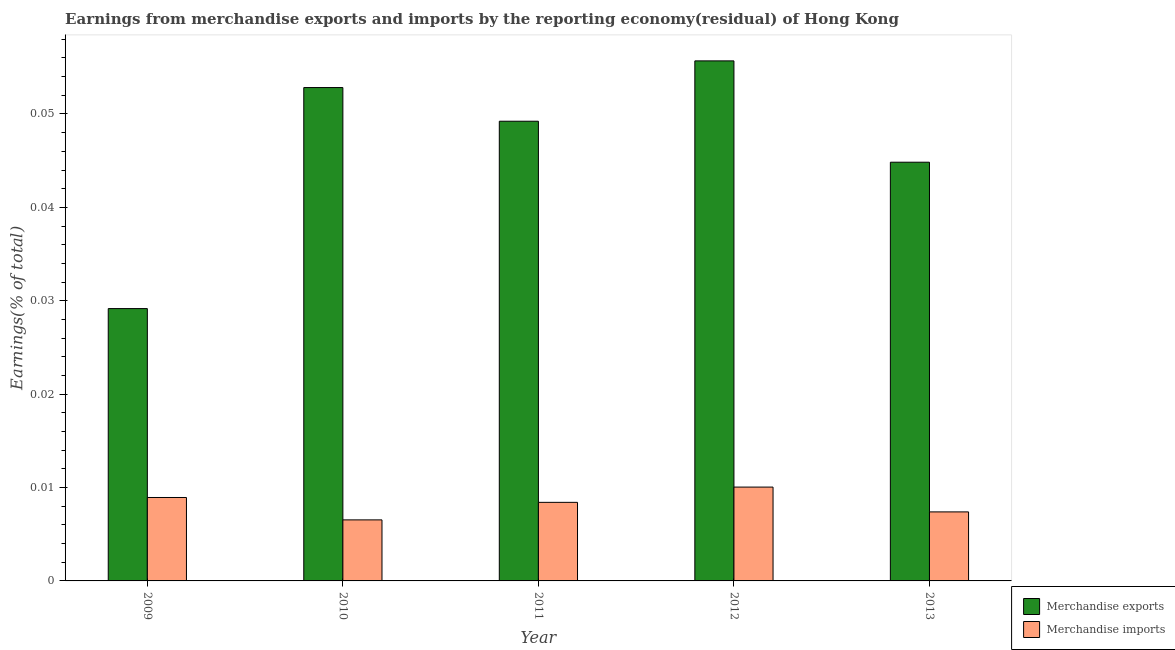How many different coloured bars are there?
Your answer should be very brief. 2. How many groups of bars are there?
Your answer should be very brief. 5. Are the number of bars per tick equal to the number of legend labels?
Your answer should be compact. Yes. Are the number of bars on each tick of the X-axis equal?
Your answer should be very brief. Yes. How many bars are there on the 3rd tick from the left?
Offer a very short reply. 2. What is the label of the 3rd group of bars from the left?
Offer a very short reply. 2011. What is the earnings from merchandise exports in 2010?
Give a very brief answer. 0.05. Across all years, what is the maximum earnings from merchandise imports?
Ensure brevity in your answer.  0.01. Across all years, what is the minimum earnings from merchandise imports?
Provide a succinct answer. 0.01. What is the total earnings from merchandise exports in the graph?
Give a very brief answer. 0.23. What is the difference between the earnings from merchandise exports in 2012 and that in 2013?
Keep it short and to the point. 0.01. What is the difference between the earnings from merchandise imports in 2011 and the earnings from merchandise exports in 2009?
Make the answer very short. -0. What is the average earnings from merchandise imports per year?
Your answer should be very brief. 0.01. In the year 2012, what is the difference between the earnings from merchandise exports and earnings from merchandise imports?
Your answer should be compact. 0. In how many years, is the earnings from merchandise exports greater than 0.044 %?
Your answer should be compact. 4. What is the ratio of the earnings from merchandise imports in 2009 to that in 2013?
Keep it short and to the point. 1.21. Is the earnings from merchandise exports in 2009 less than that in 2012?
Your answer should be compact. Yes. What is the difference between the highest and the second highest earnings from merchandise exports?
Provide a succinct answer. 0. What is the difference between the highest and the lowest earnings from merchandise imports?
Offer a very short reply. 0. In how many years, is the earnings from merchandise imports greater than the average earnings from merchandise imports taken over all years?
Ensure brevity in your answer.  3. Are all the bars in the graph horizontal?
Keep it short and to the point. No. Does the graph contain any zero values?
Your answer should be compact. No. Does the graph contain grids?
Keep it short and to the point. No. Where does the legend appear in the graph?
Ensure brevity in your answer.  Bottom right. How many legend labels are there?
Ensure brevity in your answer.  2. How are the legend labels stacked?
Make the answer very short. Vertical. What is the title of the graph?
Give a very brief answer. Earnings from merchandise exports and imports by the reporting economy(residual) of Hong Kong. Does "% of GNI" appear as one of the legend labels in the graph?
Provide a short and direct response. No. What is the label or title of the X-axis?
Keep it short and to the point. Year. What is the label or title of the Y-axis?
Provide a short and direct response. Earnings(% of total). What is the Earnings(% of total) of Merchandise exports in 2009?
Provide a succinct answer. 0.03. What is the Earnings(% of total) of Merchandise imports in 2009?
Your answer should be compact. 0.01. What is the Earnings(% of total) of Merchandise exports in 2010?
Make the answer very short. 0.05. What is the Earnings(% of total) of Merchandise imports in 2010?
Give a very brief answer. 0.01. What is the Earnings(% of total) in Merchandise exports in 2011?
Your answer should be compact. 0.05. What is the Earnings(% of total) of Merchandise imports in 2011?
Your response must be concise. 0.01. What is the Earnings(% of total) of Merchandise exports in 2012?
Keep it short and to the point. 0.06. What is the Earnings(% of total) in Merchandise imports in 2012?
Your answer should be very brief. 0.01. What is the Earnings(% of total) of Merchandise exports in 2013?
Make the answer very short. 0.04. What is the Earnings(% of total) of Merchandise imports in 2013?
Your answer should be compact. 0.01. Across all years, what is the maximum Earnings(% of total) of Merchandise exports?
Make the answer very short. 0.06. Across all years, what is the maximum Earnings(% of total) of Merchandise imports?
Make the answer very short. 0.01. Across all years, what is the minimum Earnings(% of total) of Merchandise exports?
Your response must be concise. 0.03. Across all years, what is the minimum Earnings(% of total) in Merchandise imports?
Give a very brief answer. 0.01. What is the total Earnings(% of total) in Merchandise exports in the graph?
Provide a short and direct response. 0.23. What is the total Earnings(% of total) in Merchandise imports in the graph?
Offer a very short reply. 0.04. What is the difference between the Earnings(% of total) in Merchandise exports in 2009 and that in 2010?
Give a very brief answer. -0.02. What is the difference between the Earnings(% of total) in Merchandise imports in 2009 and that in 2010?
Your response must be concise. 0. What is the difference between the Earnings(% of total) in Merchandise exports in 2009 and that in 2011?
Make the answer very short. -0.02. What is the difference between the Earnings(% of total) in Merchandise exports in 2009 and that in 2012?
Give a very brief answer. -0.03. What is the difference between the Earnings(% of total) of Merchandise imports in 2009 and that in 2012?
Provide a succinct answer. -0. What is the difference between the Earnings(% of total) of Merchandise exports in 2009 and that in 2013?
Give a very brief answer. -0.02. What is the difference between the Earnings(% of total) of Merchandise imports in 2009 and that in 2013?
Ensure brevity in your answer.  0. What is the difference between the Earnings(% of total) in Merchandise exports in 2010 and that in 2011?
Offer a very short reply. 0. What is the difference between the Earnings(% of total) in Merchandise imports in 2010 and that in 2011?
Offer a very short reply. -0. What is the difference between the Earnings(% of total) of Merchandise exports in 2010 and that in 2012?
Offer a very short reply. -0. What is the difference between the Earnings(% of total) in Merchandise imports in 2010 and that in 2012?
Ensure brevity in your answer.  -0. What is the difference between the Earnings(% of total) of Merchandise exports in 2010 and that in 2013?
Keep it short and to the point. 0.01. What is the difference between the Earnings(% of total) in Merchandise imports in 2010 and that in 2013?
Make the answer very short. -0. What is the difference between the Earnings(% of total) of Merchandise exports in 2011 and that in 2012?
Provide a short and direct response. -0.01. What is the difference between the Earnings(% of total) of Merchandise imports in 2011 and that in 2012?
Give a very brief answer. -0. What is the difference between the Earnings(% of total) in Merchandise exports in 2011 and that in 2013?
Offer a terse response. 0. What is the difference between the Earnings(% of total) of Merchandise exports in 2012 and that in 2013?
Your response must be concise. 0.01. What is the difference between the Earnings(% of total) in Merchandise imports in 2012 and that in 2013?
Provide a short and direct response. 0. What is the difference between the Earnings(% of total) in Merchandise exports in 2009 and the Earnings(% of total) in Merchandise imports in 2010?
Give a very brief answer. 0.02. What is the difference between the Earnings(% of total) of Merchandise exports in 2009 and the Earnings(% of total) of Merchandise imports in 2011?
Provide a short and direct response. 0.02. What is the difference between the Earnings(% of total) of Merchandise exports in 2009 and the Earnings(% of total) of Merchandise imports in 2012?
Give a very brief answer. 0.02. What is the difference between the Earnings(% of total) in Merchandise exports in 2009 and the Earnings(% of total) in Merchandise imports in 2013?
Your answer should be very brief. 0.02. What is the difference between the Earnings(% of total) in Merchandise exports in 2010 and the Earnings(% of total) in Merchandise imports in 2011?
Make the answer very short. 0.04. What is the difference between the Earnings(% of total) of Merchandise exports in 2010 and the Earnings(% of total) of Merchandise imports in 2012?
Offer a very short reply. 0.04. What is the difference between the Earnings(% of total) in Merchandise exports in 2010 and the Earnings(% of total) in Merchandise imports in 2013?
Give a very brief answer. 0.05. What is the difference between the Earnings(% of total) of Merchandise exports in 2011 and the Earnings(% of total) of Merchandise imports in 2012?
Give a very brief answer. 0.04. What is the difference between the Earnings(% of total) of Merchandise exports in 2011 and the Earnings(% of total) of Merchandise imports in 2013?
Your response must be concise. 0.04. What is the difference between the Earnings(% of total) of Merchandise exports in 2012 and the Earnings(% of total) of Merchandise imports in 2013?
Ensure brevity in your answer.  0.05. What is the average Earnings(% of total) of Merchandise exports per year?
Your answer should be very brief. 0.05. What is the average Earnings(% of total) of Merchandise imports per year?
Your answer should be very brief. 0.01. In the year 2009, what is the difference between the Earnings(% of total) in Merchandise exports and Earnings(% of total) in Merchandise imports?
Offer a terse response. 0.02. In the year 2010, what is the difference between the Earnings(% of total) of Merchandise exports and Earnings(% of total) of Merchandise imports?
Ensure brevity in your answer.  0.05. In the year 2011, what is the difference between the Earnings(% of total) in Merchandise exports and Earnings(% of total) in Merchandise imports?
Provide a succinct answer. 0.04. In the year 2012, what is the difference between the Earnings(% of total) in Merchandise exports and Earnings(% of total) in Merchandise imports?
Make the answer very short. 0.05. In the year 2013, what is the difference between the Earnings(% of total) of Merchandise exports and Earnings(% of total) of Merchandise imports?
Offer a very short reply. 0.04. What is the ratio of the Earnings(% of total) in Merchandise exports in 2009 to that in 2010?
Your answer should be very brief. 0.55. What is the ratio of the Earnings(% of total) in Merchandise imports in 2009 to that in 2010?
Provide a short and direct response. 1.37. What is the ratio of the Earnings(% of total) of Merchandise exports in 2009 to that in 2011?
Provide a short and direct response. 0.59. What is the ratio of the Earnings(% of total) of Merchandise imports in 2009 to that in 2011?
Provide a succinct answer. 1.06. What is the ratio of the Earnings(% of total) of Merchandise exports in 2009 to that in 2012?
Your answer should be compact. 0.52. What is the ratio of the Earnings(% of total) in Merchandise imports in 2009 to that in 2012?
Offer a very short reply. 0.89. What is the ratio of the Earnings(% of total) in Merchandise exports in 2009 to that in 2013?
Offer a terse response. 0.65. What is the ratio of the Earnings(% of total) in Merchandise imports in 2009 to that in 2013?
Ensure brevity in your answer.  1.21. What is the ratio of the Earnings(% of total) of Merchandise exports in 2010 to that in 2011?
Offer a very short reply. 1.07. What is the ratio of the Earnings(% of total) of Merchandise imports in 2010 to that in 2011?
Your answer should be compact. 0.78. What is the ratio of the Earnings(% of total) in Merchandise exports in 2010 to that in 2012?
Provide a succinct answer. 0.95. What is the ratio of the Earnings(% of total) in Merchandise imports in 2010 to that in 2012?
Provide a succinct answer. 0.65. What is the ratio of the Earnings(% of total) in Merchandise exports in 2010 to that in 2013?
Ensure brevity in your answer.  1.18. What is the ratio of the Earnings(% of total) in Merchandise imports in 2010 to that in 2013?
Keep it short and to the point. 0.88. What is the ratio of the Earnings(% of total) in Merchandise exports in 2011 to that in 2012?
Ensure brevity in your answer.  0.88. What is the ratio of the Earnings(% of total) of Merchandise imports in 2011 to that in 2012?
Offer a very short reply. 0.84. What is the ratio of the Earnings(% of total) in Merchandise exports in 2011 to that in 2013?
Offer a terse response. 1.1. What is the ratio of the Earnings(% of total) of Merchandise imports in 2011 to that in 2013?
Give a very brief answer. 1.14. What is the ratio of the Earnings(% of total) of Merchandise exports in 2012 to that in 2013?
Offer a terse response. 1.24. What is the ratio of the Earnings(% of total) in Merchandise imports in 2012 to that in 2013?
Your response must be concise. 1.36. What is the difference between the highest and the second highest Earnings(% of total) of Merchandise exports?
Give a very brief answer. 0. What is the difference between the highest and the second highest Earnings(% of total) in Merchandise imports?
Offer a terse response. 0. What is the difference between the highest and the lowest Earnings(% of total) of Merchandise exports?
Offer a terse response. 0.03. What is the difference between the highest and the lowest Earnings(% of total) in Merchandise imports?
Provide a succinct answer. 0. 